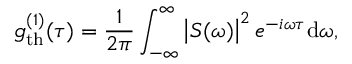<formula> <loc_0><loc_0><loc_500><loc_500>g _ { t h } ^ { ( 1 ) } ( \tau ) = \frac { 1 } { 2 \pi } \int _ { - \infty } ^ { \infty } \left | S ( \omega ) \right | ^ { 2 } e ^ { - i \omega \tau } d \omega ,</formula> 